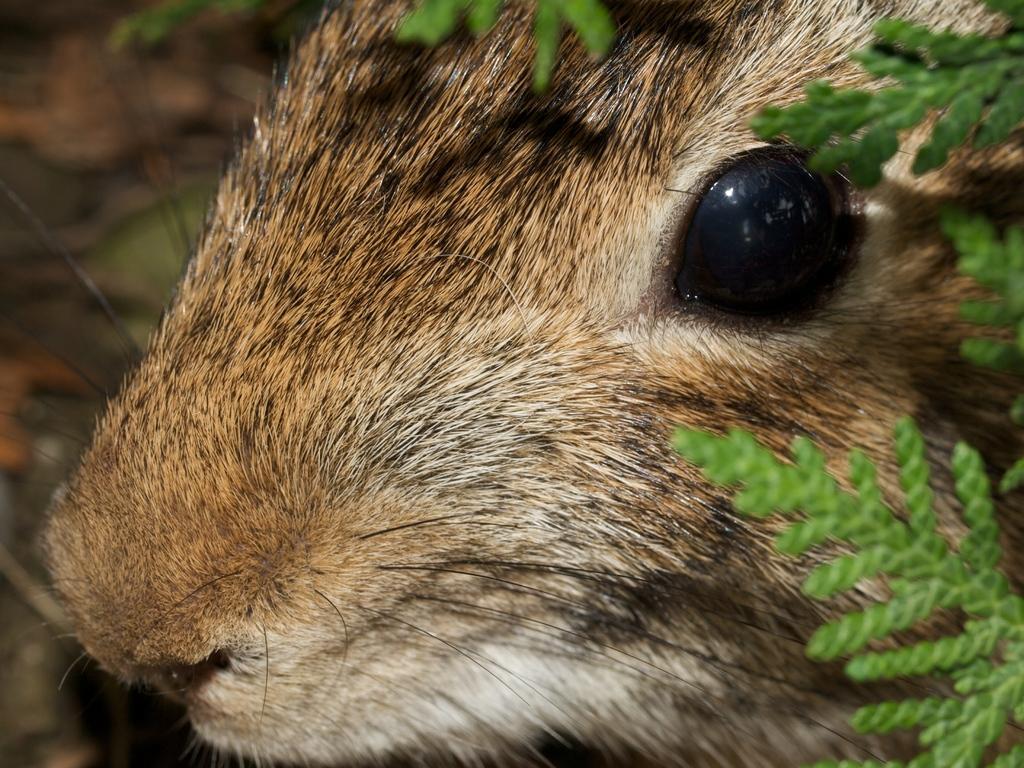Could you give a brief overview of what you see in this image? In the picture I can see a closer view of an animal, here we can see the plants and the background of the image is blurred. 